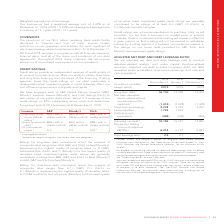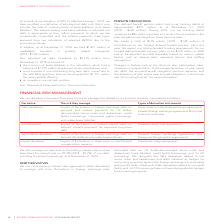According to Rogers Communications's financial document, What is used for to conduct valuation-related analysis and make capital structure-related decisions? We use adjusted net debt and debt leverage ratio to conduct valuation-related analysis and make capital structure-related decisions.. The document states: "ADJUSTED NET DEBT AND DEBT LEVERAGE RATIO We use adjusted net debt and debt leverage ratio to conduct valuation-related analysis and make capital stru..." Also, What is included in the adjusted net debt? djusted net debt includes long-term debt, net debt derivative assets or liabilities, short-term borrowings, and cash and cash equivalents.. The document states: "is and make capital structure-related decisions. Adjusted net debt includes long-term debt, net debt derivative assets or liabilities, short-term borr..." Also, Where is debt derivatives valued without adjustment for credit risk used for evaluation? For purposes of calculating adjusted net debt and debt leverage ratio, we believe including debt derivatives valued without adjustment for credit risk is commonly used to evaluate debt leverage and for market valuation and transactional purposes.. The document states: "2 For purposes of calculating adjusted net debt and debt leverage ratio, we believe including debt derivatives valued without adjustment for credit ri..." Also, can you calculate: What is the increase/ (decrease) in Long-term debt from December 31, 2018 to December 31, 2019? Based on the calculation: 16,130-14,404, the result is 1726 (in millions). This is based on the information: "Long-term debt 1 16,130 14,404 14,404 Net debt derivative assets valued without any adjustment for credit risk 2 (1,414) (1,448) ( Long-term debt 1 16,130 14,404 14,404 Net debt derivative assets valu..." The key data points involved are: 14,404, 16,130. Also, can you calculate: What is the increase/ (decrease) in Net debt derivative assets valued without any adjustment for credit risk from December 31, 2018 to December 31, 2019? Based on the calculation: 1,414-1,448, the result is -34 (in millions). This is based on the information: "valued without any adjustment for credit risk 2 (1,414) (1,448) (1,448) Short-term borrowings 2,238 2,255 2,255 Lease liabilities 3 1,725 1,545 – Cash and without any adjustment for credit risk 2 (1,4..." The key data points involved are: 1,414, 1,448. Also, can you calculate: What is the increase/ (decrease) in Cash and cash equivalents from December 31, 2018 to December 31, 2019? Based on the calculation: 494-405, the result is 89 (in millions). This is based on the information: "lities 3 1,725 1,545 – Cash and cash equivalents (494) (405) (405) 3 1,725 1,545 – Cash and cash equivalents (494) (405) (405)..." The key data points involved are: 405, 494. 